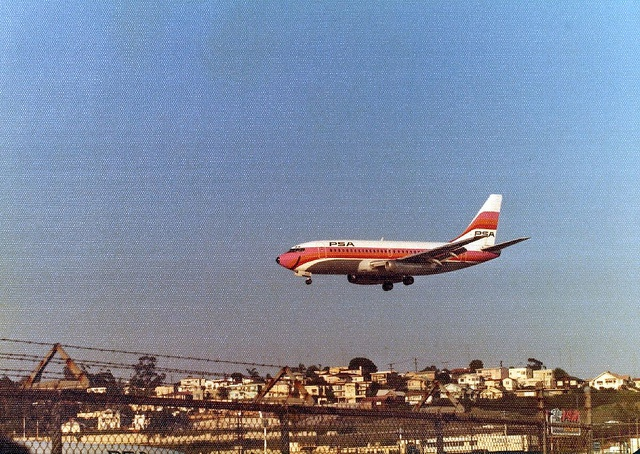Describe the objects in this image and their specific colors. I can see a airplane in lightblue, black, ivory, maroon, and salmon tones in this image. 